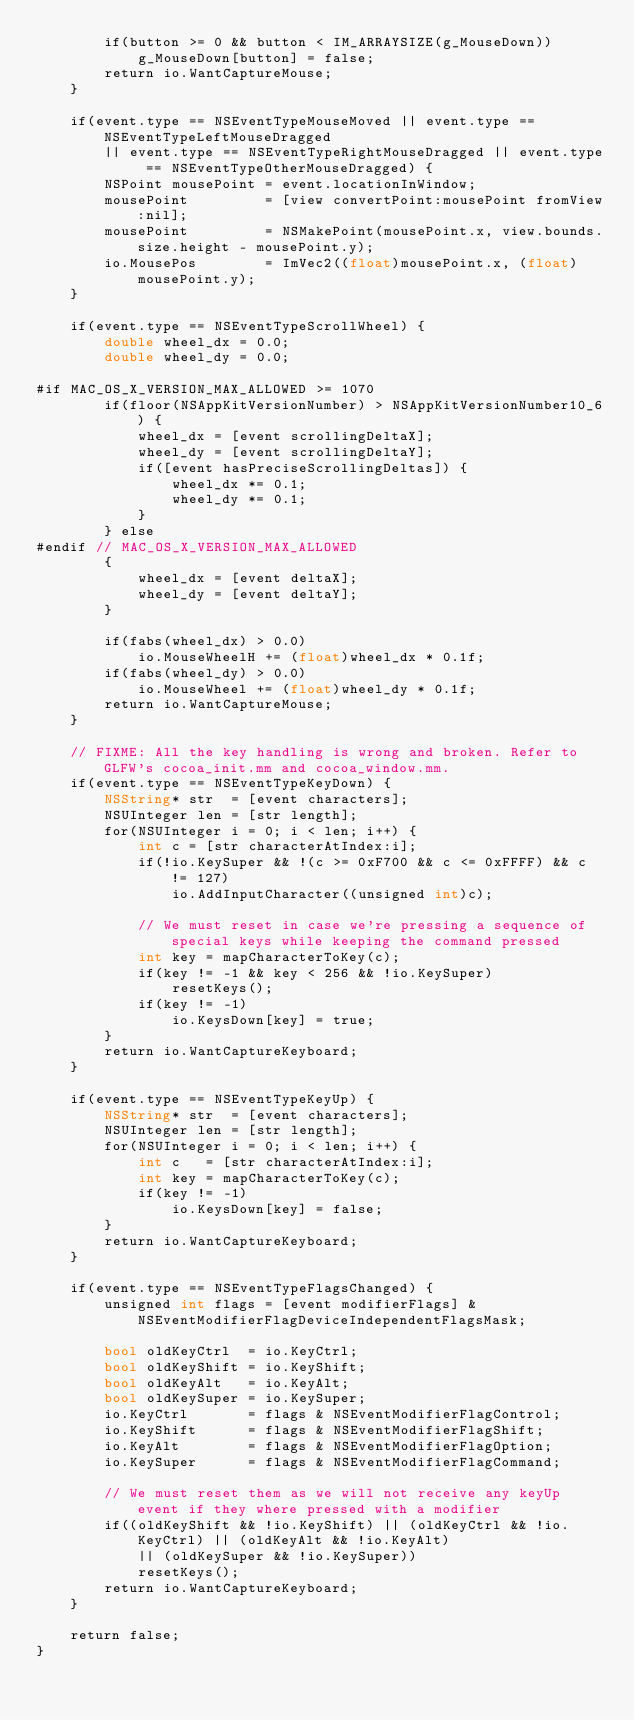<code> <loc_0><loc_0><loc_500><loc_500><_ObjectiveC_>		if(button >= 0 && button < IM_ARRAYSIZE(g_MouseDown))
			g_MouseDown[button] = false;
		return io.WantCaptureMouse;
	}

	if(event.type == NSEventTypeMouseMoved || event.type == NSEventTypeLeftMouseDragged
		|| event.type == NSEventTypeRightMouseDragged || event.type == NSEventTypeOtherMouseDragged) {
		NSPoint mousePoint = event.locationInWindow;
		mousePoint         = [view convertPoint:mousePoint fromView:nil];
		mousePoint         = NSMakePoint(mousePoint.x, view.bounds.size.height - mousePoint.y);
		io.MousePos        = ImVec2((float)mousePoint.x, (float)mousePoint.y);
	}

	if(event.type == NSEventTypeScrollWheel) {
		double wheel_dx = 0.0;
		double wheel_dy = 0.0;

#if MAC_OS_X_VERSION_MAX_ALLOWED >= 1070
		if(floor(NSAppKitVersionNumber) > NSAppKitVersionNumber10_6) {
			wheel_dx = [event scrollingDeltaX];
			wheel_dy = [event scrollingDeltaY];
			if([event hasPreciseScrollingDeltas]) {
				wheel_dx *= 0.1;
				wheel_dy *= 0.1;
			}
		} else
#endif // MAC_OS_X_VERSION_MAX_ALLOWED
		{
			wheel_dx = [event deltaX];
			wheel_dy = [event deltaY];
		}

		if(fabs(wheel_dx) > 0.0)
			io.MouseWheelH += (float)wheel_dx * 0.1f;
		if(fabs(wheel_dy) > 0.0)
			io.MouseWheel += (float)wheel_dy * 0.1f;
		return io.WantCaptureMouse;
	}

	// FIXME: All the key handling is wrong and broken. Refer to GLFW's cocoa_init.mm and cocoa_window.mm.
	if(event.type == NSEventTypeKeyDown) {
		NSString* str  = [event characters];
		NSUInteger len = [str length];
		for(NSUInteger i = 0; i < len; i++) {
			int c = [str characterAtIndex:i];
			if(!io.KeySuper && !(c >= 0xF700 && c <= 0xFFFF) && c != 127)
				io.AddInputCharacter((unsigned int)c);

			// We must reset in case we're pressing a sequence of special keys while keeping the command pressed
			int key = mapCharacterToKey(c);
			if(key != -1 && key < 256 && !io.KeySuper)
				resetKeys();
			if(key != -1)
				io.KeysDown[key] = true;
		}
		return io.WantCaptureKeyboard;
	}

	if(event.type == NSEventTypeKeyUp) {
		NSString* str  = [event characters];
		NSUInteger len = [str length];
		for(NSUInteger i = 0; i < len; i++) {
			int c   = [str characterAtIndex:i];
			int key = mapCharacterToKey(c);
			if(key != -1)
				io.KeysDown[key] = false;
		}
		return io.WantCaptureKeyboard;
	}

	if(event.type == NSEventTypeFlagsChanged) {
		unsigned int flags = [event modifierFlags] & NSEventModifierFlagDeviceIndependentFlagsMask;

		bool oldKeyCtrl  = io.KeyCtrl;
		bool oldKeyShift = io.KeyShift;
		bool oldKeyAlt   = io.KeyAlt;
		bool oldKeySuper = io.KeySuper;
		io.KeyCtrl       = flags & NSEventModifierFlagControl;
		io.KeyShift      = flags & NSEventModifierFlagShift;
		io.KeyAlt        = flags & NSEventModifierFlagOption;
		io.KeySuper      = flags & NSEventModifierFlagCommand;

		// We must reset them as we will not receive any keyUp event if they where pressed with a modifier
		if((oldKeyShift && !io.KeyShift) || (oldKeyCtrl && !io.KeyCtrl) || (oldKeyAlt && !io.KeyAlt)
			|| (oldKeySuper && !io.KeySuper))
			resetKeys();
		return io.WantCaptureKeyboard;
	}

	return false;
}
</code> 